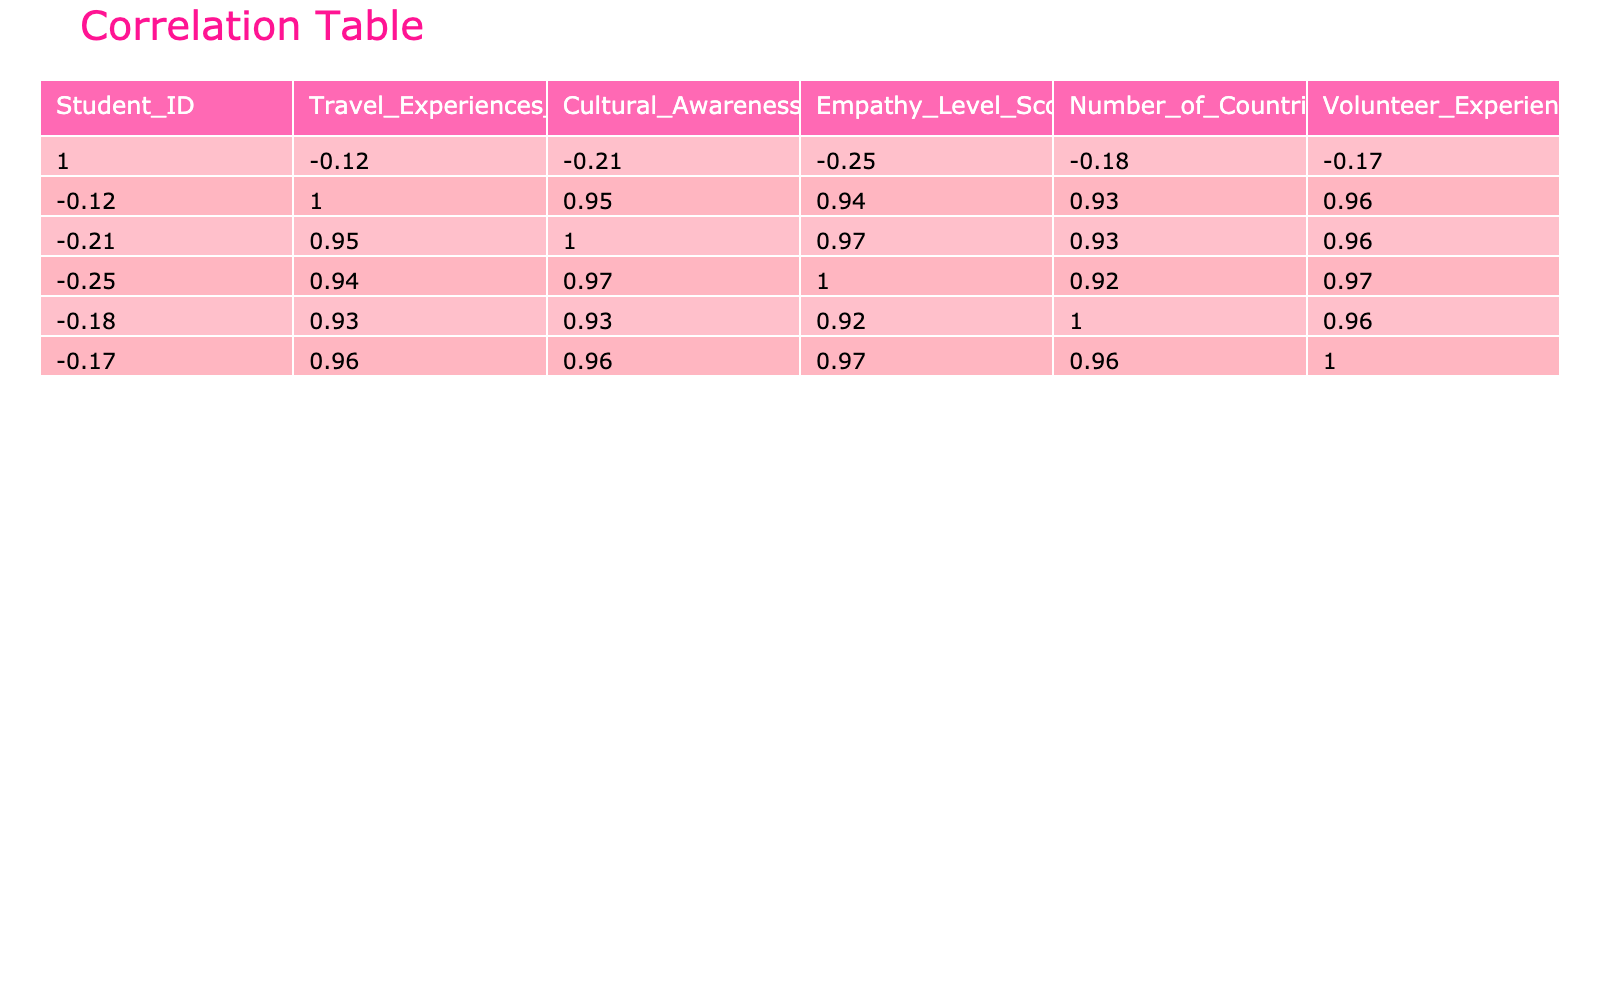What is the correlation between Travel Experiences Duration and Cultural Awareness Score? The correlation value between Travel Experiences Duration (in months) and Cultural Awareness Score from the table is found by looking at the corresponding cell in the correlation matrix. It indicates how strongly these two variables are related.
Answer: The correlation is 0.91 What is the total number of Volunteer Experience Hours for all students? To find the total, we sum up the Volunteer Experience Hours for each student: 40 + 60 + 20 + 50 + 10 + 70 + 55 + 15 + 65 + 5 = 390.
Answer: 390 Is there a student with more than one country visited who has a Cultural Awareness Score below 80? To determine this, we need to look through the data for students with more than one country visited and check their Cultural Awareness Scores. Only student 3 visited 2 countries and has a Cultural Awareness Score of 70, which is below 80.
Answer: Yes What is the average Empathy Level Score for students who traveled for more than 7 months? We identify students with a Travel Experiences Duration greater than 7 months: students 2, 4, 6, 7, and 9. Their Empathy Level Scores are 85, 82, 88, 80, and 86 respectively. The sum is 85 + 82 + 88 + 80 + 86 = 421, and the average score is 421 / 5 = 84.2.
Answer: 84.2 Is there a direct relationship between the number of countries visited and the Cultural Awareness Score? A direct relationship suggests that when the number of countries visited increases, the Cultural Awareness Score will also increase. Looking at the correlation value from the table, we find it to be 0.78, indicating a positive correlation.
Answer: Yes 